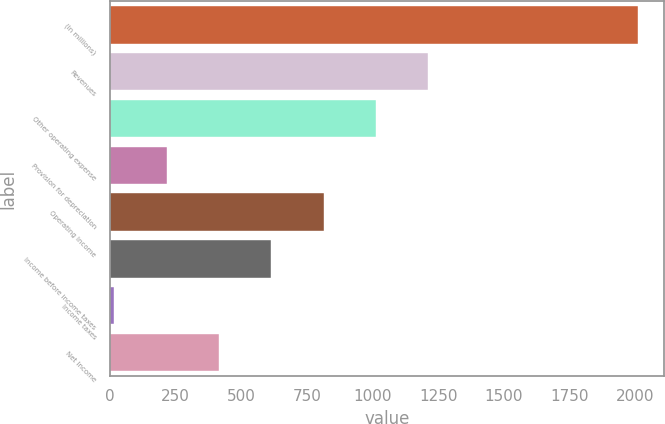Convert chart. <chart><loc_0><loc_0><loc_500><loc_500><bar_chart><fcel>(In millions)<fcel>Revenues<fcel>Other operating expense<fcel>Provision for depreciation<fcel>Operating Income<fcel>Income before income taxes<fcel>Income taxes<fcel>Net Income<nl><fcel>2011<fcel>1213<fcel>1013.5<fcel>215.5<fcel>814<fcel>614.5<fcel>16<fcel>415<nl></chart> 